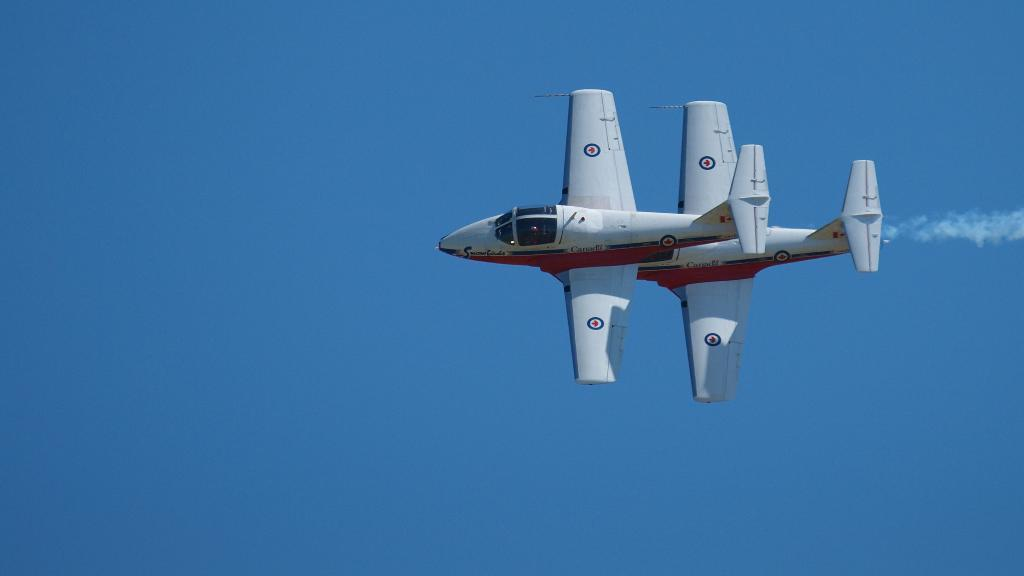What is the main subject of the image? The main subject of the image is an airplane. Where is the airplane located in the image? The airplane is in the sky. What language is the minister speaking to the stove in the image? There is no minister or stove present in the image; it only features an airplane in the sky. 